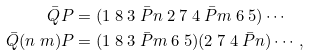Convert formula to latex. <formula><loc_0><loc_0><loc_500><loc_500>\bar { Q } P & = ( 1 \ 8 \ 3 \ \bar { P } n \ 2 \ 7 \ 4 \ \bar { P } m \ 6 \ 5 ) \cdots \\ \bar { Q } ( n \ m ) P & = ( 1 \ 8 \ 3 \ \bar { P } m \ 6 \ 5 ) ( 2 \ 7 \ 4 \ \bar { P } n ) \cdots ,</formula> 